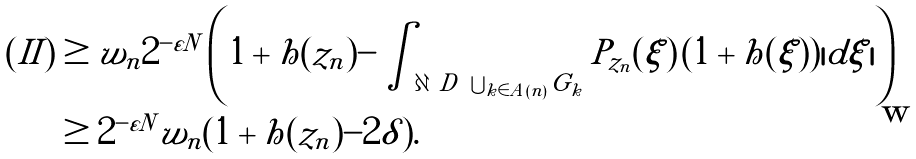<formula> <loc_0><loc_0><loc_500><loc_500>( I I ) & \geq w _ { n } 2 ^ { - \varepsilon N } \left ( 1 + h ( z _ { n } ) - \int _ { \partial \ D \ \bigcup _ { k \in A ( n ) } G _ { k } } P _ { z _ { n } } ( \xi ) \, ( 1 + h ( \xi ) ) | d \xi | \right ) \\ & \geq 2 ^ { - \varepsilon N } w _ { n } ( 1 + h ( z _ { n } ) - 2 \delta ) .</formula> 